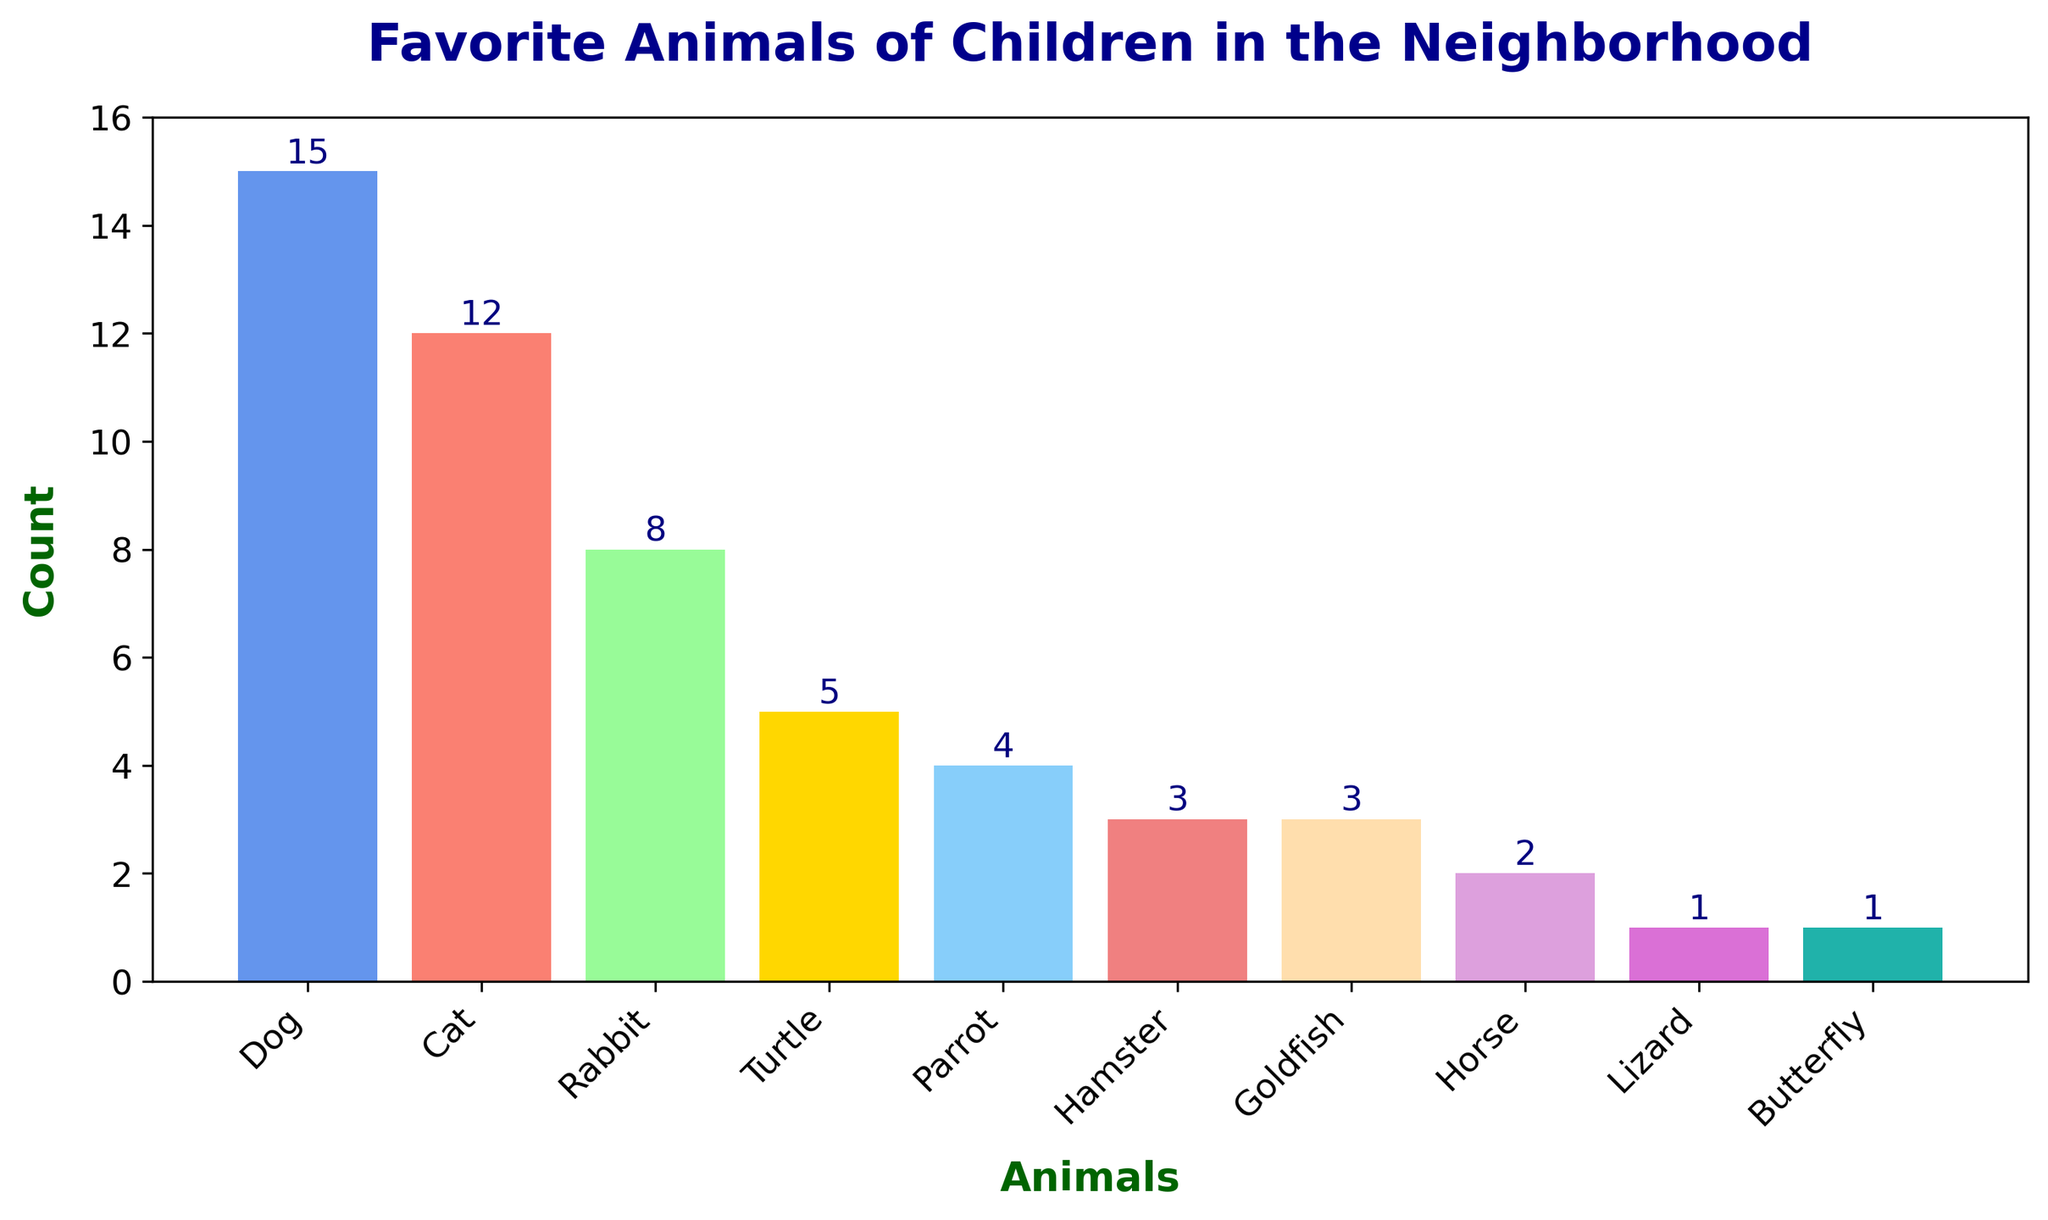what is the most popular animal among the children? The bar with the highest height represents the most popular animal. Look for the bar that is tallest and its corresponding label.
Answer: Dog which animal has a count of 8? Identify the bar with a height corresponding to 8 on the y-axis and find out the label for that bar.
Answer: Rabbit how many more children like dogs than cats? The bar for dogs is at 15, and the bar for cats is at 12. Subtract the count for cats from the count for dogs, which is 15 - 12.
Answer: 3 are there more children who like turtles or parrots? Compare the heights of the bars for turtles and parrots. The bar for turtles is at 5, and the bar for parrots is at 4.
Answer: Turtles which animals have the same count of preferences? Look for bars that have the same height. The bars for Hamster and Goldfish both are at 3.
Answer: Hamster and Goldfish how many children like either dogs or cats? Add the counts for dogs (15) and cats (12). The sum is 15 + 12.
Answer: 27 what is the least popular animal? The bar with the smallest height represents the least popular animal. Identify this bar and its label.
Answer: Butterfly which animal has a taller bar, the parrot or the hamster? Compare the heights of the bars for parrots and hamsters. The bar for parrots is higher at 4 compared to the bar for hamsters at 3.
Answer: Parrot is the number of children who like cats greater than those who like rabbits? Compare the heights of the bars for cats and rabbits. The bar for cats is taller (12 compared to 8).
Answer: Yes combine the counts of the three least popular animals. what is the total? Identify the three shortest bars, which represent Butterfly (1), Lizard (1), and Horse (2). Add their counts: 1 + 1 + 2.
Answer: 4 